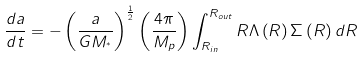Convert formula to latex. <formula><loc_0><loc_0><loc_500><loc_500>\frac { d a } { d t } = - \left ( \frac { a } { G M _ { ^ { * } } } \right ) ^ { \frac { 1 } { 2 } } \left ( \frac { 4 \pi } { M _ { p } } \right ) \int ^ { R _ { o u t } } _ { R _ { i n } } R \Lambda \left ( R \right ) \Sigma \left ( R \right ) d R</formula> 